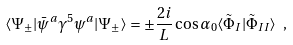<formula> <loc_0><loc_0><loc_500><loc_500>\langle \Psi _ { \pm } | \bar { \psi } ^ { a } \gamma ^ { 5 } \psi ^ { a } | \Psi _ { \pm } \rangle = \pm \frac { 2 i } { L } \cos \alpha _ { 0 } \langle \tilde { \Phi } _ { I } | \tilde { \Phi } _ { I I } \rangle \ ,</formula> 